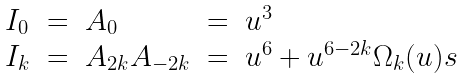<formula> <loc_0><loc_0><loc_500><loc_500>\begin{array} { l l l l l } I _ { 0 } & = & A _ { 0 } & = & u ^ { 3 } \\ I _ { k } & = & A _ { 2 k } A _ { - 2 k } & = & u ^ { 6 } + u ^ { 6 - 2 k } \Omega _ { k } ( u ) s \end{array}</formula> 